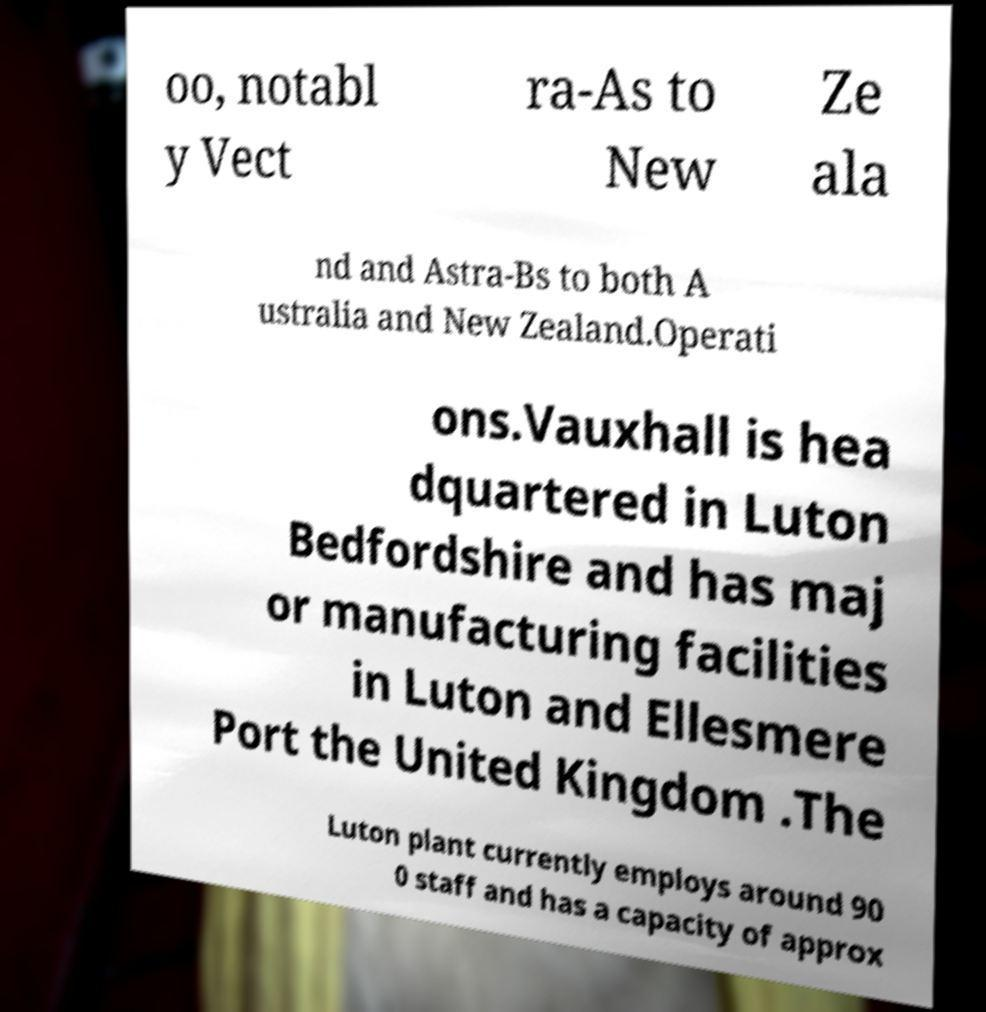I need the written content from this picture converted into text. Can you do that? oo, notabl y Vect ra-As to New Ze ala nd and Astra-Bs to both A ustralia and New Zealand.Operati ons.Vauxhall is hea dquartered in Luton Bedfordshire and has maj or manufacturing facilities in Luton and Ellesmere Port the United Kingdom .The Luton plant currently employs around 90 0 staff and has a capacity of approx 